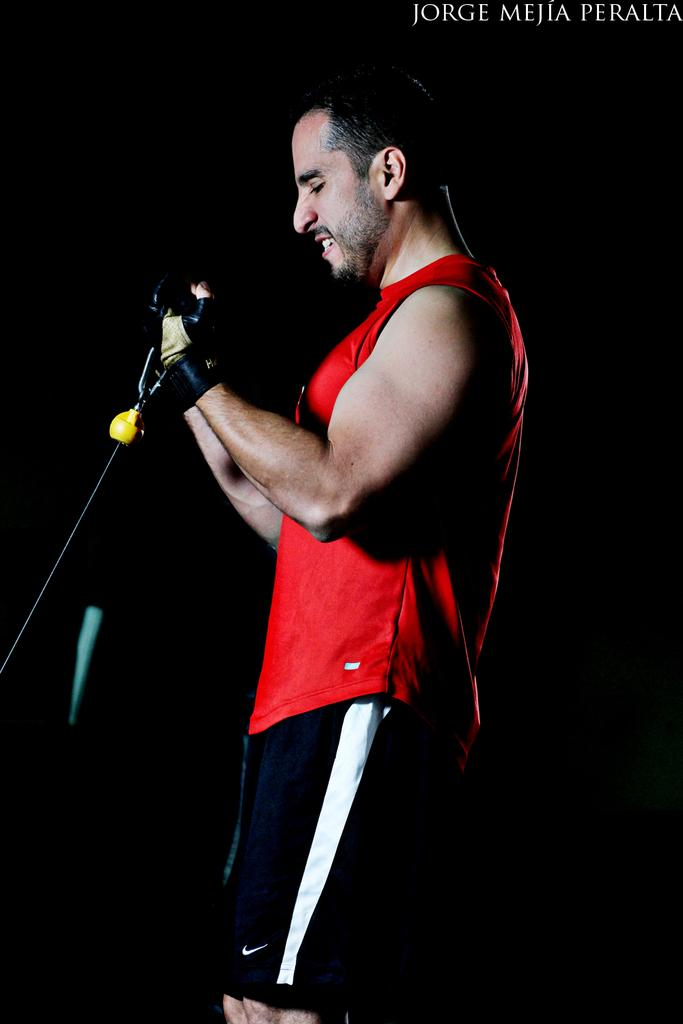What is the main subject of the image? The main subject of the image is a man standing in the center. What is the man holding in the image? The man is holding an object in the image. How would you describe the background of the image? The background of the image is dark. Can you identify any text in the image? Yes, there is text in the top right corner of the image. What type of shock can be seen affecting the committee in the image? There is no committee or shock present in the image; it features a man standing in the center holding an object. Can you tell me how many trains are visible in the image? There are no trains present in the image. 